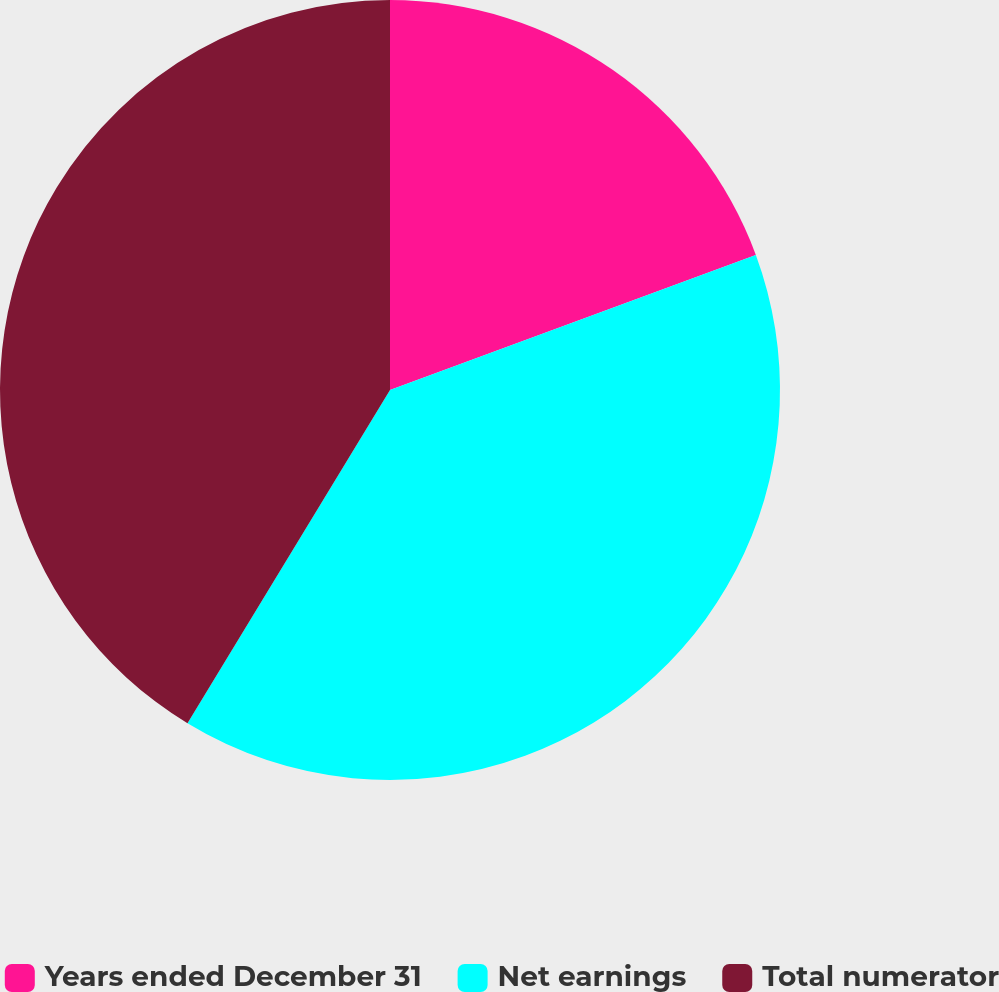Convert chart to OTSL. <chart><loc_0><loc_0><loc_500><loc_500><pie_chart><fcel>Years ended December 31<fcel>Net earnings<fcel>Total numerator<nl><fcel>19.37%<fcel>39.32%<fcel>41.31%<nl></chart> 